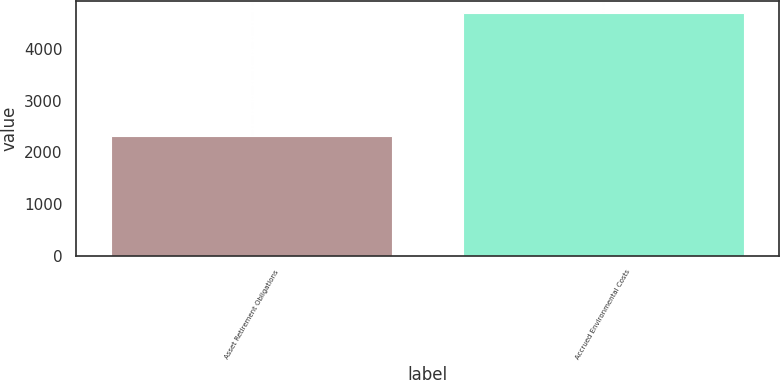<chart> <loc_0><loc_0><loc_500><loc_500><bar_chart><fcel>Asset Retirement Obligations<fcel>Accrued Environmental Costs<nl><fcel>2314<fcel>4698<nl></chart> 